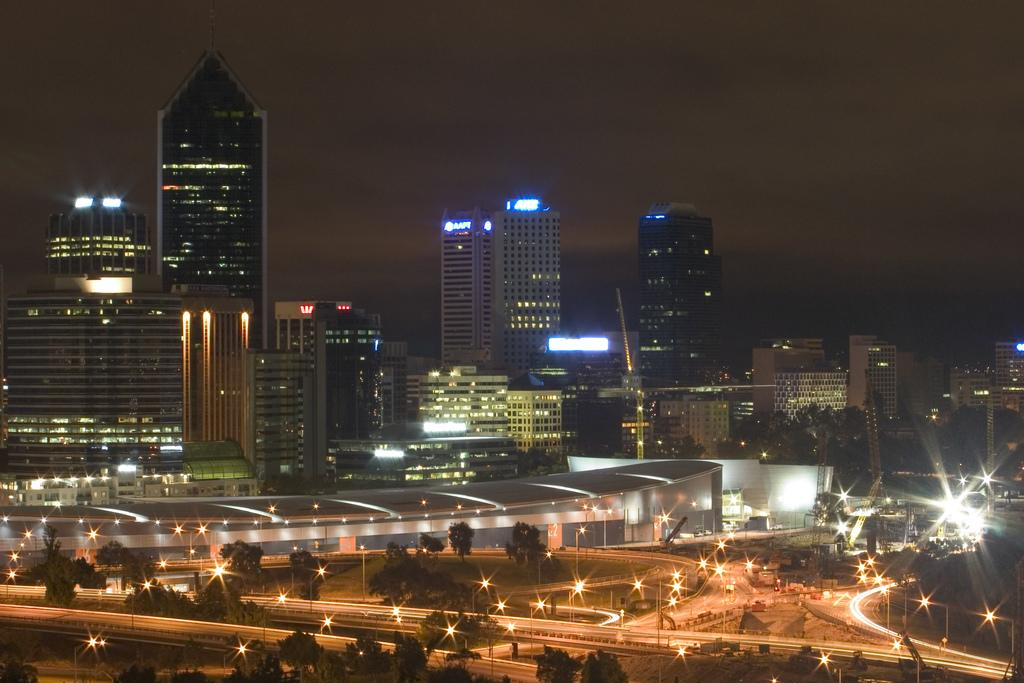What type of natural elements can be seen in the image? There are trees in the image. What type of man-made structures can be seen in the image? There are buildings in the image. What type of transportation infrastructure can be seen in the image? There are roads in the image. What is visible in the background of the image? The sky is visible in the background of the image. What type of calculator can be seen on the tree in the image? There is no calculator present in the image; it features trees, roads, buildings, and the sky. What color is the hair on the tree in the image? There is no hair present in the image; it features trees, roads, buildings, and the sky. 